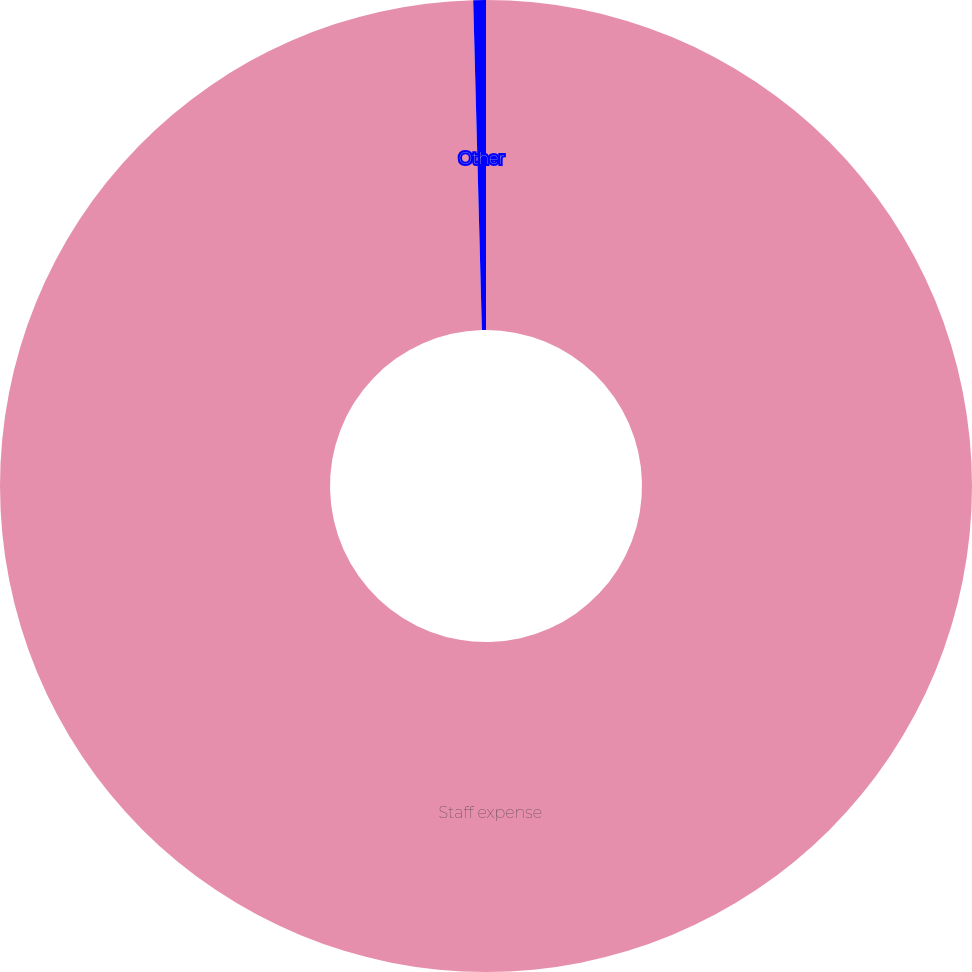<chart> <loc_0><loc_0><loc_500><loc_500><pie_chart><fcel>Staff expense<fcel>Other<nl><fcel>99.58%<fcel>0.42%<nl></chart> 